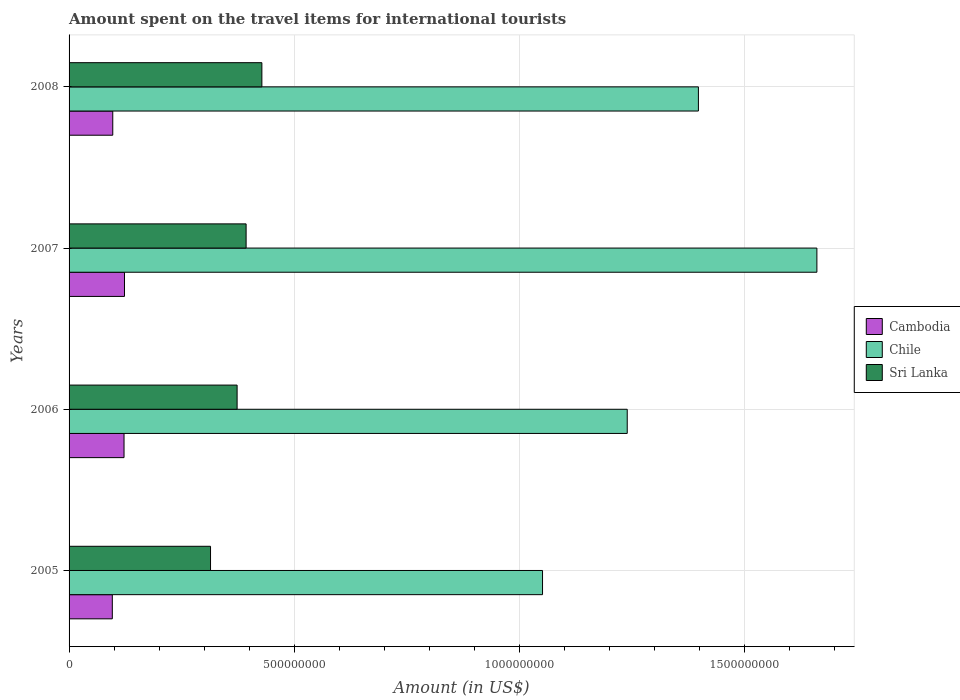How many different coloured bars are there?
Your response must be concise. 3. Are the number of bars per tick equal to the number of legend labels?
Ensure brevity in your answer.  Yes. Are the number of bars on each tick of the Y-axis equal?
Your response must be concise. Yes. How many bars are there on the 4th tick from the bottom?
Your response must be concise. 3. In how many cases, is the number of bars for a given year not equal to the number of legend labels?
Ensure brevity in your answer.  0. What is the amount spent on the travel items for international tourists in Cambodia in 2005?
Your response must be concise. 9.60e+07. Across all years, what is the maximum amount spent on the travel items for international tourists in Chile?
Provide a succinct answer. 1.66e+09. Across all years, what is the minimum amount spent on the travel items for international tourists in Cambodia?
Provide a short and direct response. 9.60e+07. What is the total amount spent on the travel items for international tourists in Cambodia in the graph?
Ensure brevity in your answer.  4.38e+08. What is the difference between the amount spent on the travel items for international tourists in Sri Lanka in 2007 and that in 2008?
Provide a succinct answer. -3.50e+07. What is the difference between the amount spent on the travel items for international tourists in Chile in 2005 and the amount spent on the travel items for international tourists in Sri Lanka in 2007?
Offer a terse response. 6.58e+08. What is the average amount spent on the travel items for international tourists in Sri Lanka per year?
Give a very brief answer. 3.77e+08. In the year 2005, what is the difference between the amount spent on the travel items for international tourists in Chile and amount spent on the travel items for international tourists in Cambodia?
Your response must be concise. 9.55e+08. What is the ratio of the amount spent on the travel items for international tourists in Chile in 2007 to that in 2008?
Offer a terse response. 1.19. Is the difference between the amount spent on the travel items for international tourists in Chile in 2007 and 2008 greater than the difference between the amount spent on the travel items for international tourists in Cambodia in 2007 and 2008?
Keep it short and to the point. Yes. What is the difference between the highest and the second highest amount spent on the travel items for international tourists in Chile?
Provide a succinct answer. 2.63e+08. What is the difference between the highest and the lowest amount spent on the travel items for international tourists in Sri Lanka?
Keep it short and to the point. 1.14e+08. In how many years, is the amount spent on the travel items for international tourists in Chile greater than the average amount spent on the travel items for international tourists in Chile taken over all years?
Provide a succinct answer. 2. What does the 1st bar from the top in 2006 represents?
Your answer should be very brief. Sri Lanka. What does the 3rd bar from the bottom in 2005 represents?
Offer a very short reply. Sri Lanka. Is it the case that in every year, the sum of the amount spent on the travel items for international tourists in Chile and amount spent on the travel items for international tourists in Sri Lanka is greater than the amount spent on the travel items for international tourists in Cambodia?
Your answer should be very brief. Yes. How many bars are there?
Your response must be concise. 12. Are all the bars in the graph horizontal?
Your answer should be compact. Yes. How many years are there in the graph?
Give a very brief answer. 4. What is the difference between two consecutive major ticks on the X-axis?
Give a very brief answer. 5.00e+08. Does the graph contain any zero values?
Offer a very short reply. No. Where does the legend appear in the graph?
Your response must be concise. Center right. What is the title of the graph?
Your response must be concise. Amount spent on the travel items for international tourists. Does "Bahrain" appear as one of the legend labels in the graph?
Provide a short and direct response. No. What is the label or title of the X-axis?
Offer a terse response. Amount (in US$). What is the Amount (in US$) of Cambodia in 2005?
Keep it short and to the point. 9.60e+07. What is the Amount (in US$) in Chile in 2005?
Offer a very short reply. 1.05e+09. What is the Amount (in US$) in Sri Lanka in 2005?
Provide a short and direct response. 3.14e+08. What is the Amount (in US$) of Cambodia in 2006?
Your response must be concise. 1.22e+08. What is the Amount (in US$) in Chile in 2006?
Keep it short and to the point. 1.24e+09. What is the Amount (in US$) in Sri Lanka in 2006?
Offer a very short reply. 3.73e+08. What is the Amount (in US$) in Cambodia in 2007?
Your response must be concise. 1.23e+08. What is the Amount (in US$) in Chile in 2007?
Your response must be concise. 1.66e+09. What is the Amount (in US$) of Sri Lanka in 2007?
Your answer should be very brief. 3.93e+08. What is the Amount (in US$) of Cambodia in 2008?
Offer a terse response. 9.70e+07. What is the Amount (in US$) in Chile in 2008?
Provide a succinct answer. 1.40e+09. What is the Amount (in US$) of Sri Lanka in 2008?
Provide a succinct answer. 4.28e+08. Across all years, what is the maximum Amount (in US$) in Cambodia?
Make the answer very short. 1.23e+08. Across all years, what is the maximum Amount (in US$) in Chile?
Ensure brevity in your answer.  1.66e+09. Across all years, what is the maximum Amount (in US$) in Sri Lanka?
Your answer should be compact. 4.28e+08. Across all years, what is the minimum Amount (in US$) of Cambodia?
Offer a very short reply. 9.60e+07. Across all years, what is the minimum Amount (in US$) of Chile?
Give a very brief answer. 1.05e+09. Across all years, what is the minimum Amount (in US$) in Sri Lanka?
Offer a very short reply. 3.14e+08. What is the total Amount (in US$) in Cambodia in the graph?
Give a very brief answer. 4.38e+08. What is the total Amount (in US$) in Chile in the graph?
Offer a very short reply. 5.35e+09. What is the total Amount (in US$) of Sri Lanka in the graph?
Keep it short and to the point. 1.51e+09. What is the difference between the Amount (in US$) in Cambodia in 2005 and that in 2006?
Your answer should be compact. -2.60e+07. What is the difference between the Amount (in US$) in Chile in 2005 and that in 2006?
Keep it short and to the point. -1.88e+08. What is the difference between the Amount (in US$) in Sri Lanka in 2005 and that in 2006?
Offer a terse response. -5.90e+07. What is the difference between the Amount (in US$) of Cambodia in 2005 and that in 2007?
Provide a succinct answer. -2.70e+07. What is the difference between the Amount (in US$) of Chile in 2005 and that in 2007?
Give a very brief answer. -6.09e+08. What is the difference between the Amount (in US$) of Sri Lanka in 2005 and that in 2007?
Your answer should be compact. -7.90e+07. What is the difference between the Amount (in US$) of Cambodia in 2005 and that in 2008?
Your answer should be very brief. -1.00e+06. What is the difference between the Amount (in US$) of Chile in 2005 and that in 2008?
Your answer should be very brief. -3.46e+08. What is the difference between the Amount (in US$) of Sri Lanka in 2005 and that in 2008?
Provide a short and direct response. -1.14e+08. What is the difference between the Amount (in US$) in Cambodia in 2006 and that in 2007?
Your answer should be compact. -1.00e+06. What is the difference between the Amount (in US$) in Chile in 2006 and that in 2007?
Your response must be concise. -4.21e+08. What is the difference between the Amount (in US$) in Sri Lanka in 2006 and that in 2007?
Offer a terse response. -2.00e+07. What is the difference between the Amount (in US$) of Cambodia in 2006 and that in 2008?
Ensure brevity in your answer.  2.50e+07. What is the difference between the Amount (in US$) in Chile in 2006 and that in 2008?
Provide a short and direct response. -1.58e+08. What is the difference between the Amount (in US$) of Sri Lanka in 2006 and that in 2008?
Your response must be concise. -5.50e+07. What is the difference between the Amount (in US$) of Cambodia in 2007 and that in 2008?
Your response must be concise. 2.60e+07. What is the difference between the Amount (in US$) in Chile in 2007 and that in 2008?
Provide a short and direct response. 2.63e+08. What is the difference between the Amount (in US$) in Sri Lanka in 2007 and that in 2008?
Keep it short and to the point. -3.50e+07. What is the difference between the Amount (in US$) in Cambodia in 2005 and the Amount (in US$) in Chile in 2006?
Your response must be concise. -1.14e+09. What is the difference between the Amount (in US$) of Cambodia in 2005 and the Amount (in US$) of Sri Lanka in 2006?
Provide a short and direct response. -2.77e+08. What is the difference between the Amount (in US$) of Chile in 2005 and the Amount (in US$) of Sri Lanka in 2006?
Your answer should be compact. 6.78e+08. What is the difference between the Amount (in US$) in Cambodia in 2005 and the Amount (in US$) in Chile in 2007?
Ensure brevity in your answer.  -1.56e+09. What is the difference between the Amount (in US$) of Cambodia in 2005 and the Amount (in US$) of Sri Lanka in 2007?
Your answer should be very brief. -2.97e+08. What is the difference between the Amount (in US$) in Chile in 2005 and the Amount (in US$) in Sri Lanka in 2007?
Your response must be concise. 6.58e+08. What is the difference between the Amount (in US$) in Cambodia in 2005 and the Amount (in US$) in Chile in 2008?
Your response must be concise. -1.30e+09. What is the difference between the Amount (in US$) in Cambodia in 2005 and the Amount (in US$) in Sri Lanka in 2008?
Your response must be concise. -3.32e+08. What is the difference between the Amount (in US$) of Chile in 2005 and the Amount (in US$) of Sri Lanka in 2008?
Make the answer very short. 6.23e+08. What is the difference between the Amount (in US$) in Cambodia in 2006 and the Amount (in US$) in Chile in 2007?
Offer a very short reply. -1.54e+09. What is the difference between the Amount (in US$) of Cambodia in 2006 and the Amount (in US$) of Sri Lanka in 2007?
Your answer should be compact. -2.71e+08. What is the difference between the Amount (in US$) in Chile in 2006 and the Amount (in US$) in Sri Lanka in 2007?
Provide a succinct answer. 8.46e+08. What is the difference between the Amount (in US$) of Cambodia in 2006 and the Amount (in US$) of Chile in 2008?
Give a very brief answer. -1.28e+09. What is the difference between the Amount (in US$) in Cambodia in 2006 and the Amount (in US$) in Sri Lanka in 2008?
Give a very brief answer. -3.06e+08. What is the difference between the Amount (in US$) of Chile in 2006 and the Amount (in US$) of Sri Lanka in 2008?
Offer a terse response. 8.11e+08. What is the difference between the Amount (in US$) in Cambodia in 2007 and the Amount (in US$) in Chile in 2008?
Your response must be concise. -1.27e+09. What is the difference between the Amount (in US$) in Cambodia in 2007 and the Amount (in US$) in Sri Lanka in 2008?
Offer a terse response. -3.05e+08. What is the difference between the Amount (in US$) of Chile in 2007 and the Amount (in US$) of Sri Lanka in 2008?
Your answer should be compact. 1.23e+09. What is the average Amount (in US$) in Cambodia per year?
Keep it short and to the point. 1.10e+08. What is the average Amount (in US$) in Chile per year?
Offer a very short reply. 1.34e+09. What is the average Amount (in US$) of Sri Lanka per year?
Your answer should be very brief. 3.77e+08. In the year 2005, what is the difference between the Amount (in US$) in Cambodia and Amount (in US$) in Chile?
Your answer should be compact. -9.55e+08. In the year 2005, what is the difference between the Amount (in US$) in Cambodia and Amount (in US$) in Sri Lanka?
Keep it short and to the point. -2.18e+08. In the year 2005, what is the difference between the Amount (in US$) of Chile and Amount (in US$) of Sri Lanka?
Offer a very short reply. 7.37e+08. In the year 2006, what is the difference between the Amount (in US$) in Cambodia and Amount (in US$) in Chile?
Your answer should be very brief. -1.12e+09. In the year 2006, what is the difference between the Amount (in US$) of Cambodia and Amount (in US$) of Sri Lanka?
Your answer should be compact. -2.51e+08. In the year 2006, what is the difference between the Amount (in US$) of Chile and Amount (in US$) of Sri Lanka?
Keep it short and to the point. 8.66e+08. In the year 2007, what is the difference between the Amount (in US$) of Cambodia and Amount (in US$) of Chile?
Offer a very short reply. -1.54e+09. In the year 2007, what is the difference between the Amount (in US$) in Cambodia and Amount (in US$) in Sri Lanka?
Offer a very short reply. -2.70e+08. In the year 2007, what is the difference between the Amount (in US$) of Chile and Amount (in US$) of Sri Lanka?
Offer a terse response. 1.27e+09. In the year 2008, what is the difference between the Amount (in US$) of Cambodia and Amount (in US$) of Chile?
Your answer should be compact. -1.30e+09. In the year 2008, what is the difference between the Amount (in US$) of Cambodia and Amount (in US$) of Sri Lanka?
Your answer should be very brief. -3.31e+08. In the year 2008, what is the difference between the Amount (in US$) in Chile and Amount (in US$) in Sri Lanka?
Your response must be concise. 9.69e+08. What is the ratio of the Amount (in US$) of Cambodia in 2005 to that in 2006?
Give a very brief answer. 0.79. What is the ratio of the Amount (in US$) in Chile in 2005 to that in 2006?
Make the answer very short. 0.85. What is the ratio of the Amount (in US$) in Sri Lanka in 2005 to that in 2006?
Provide a succinct answer. 0.84. What is the ratio of the Amount (in US$) in Cambodia in 2005 to that in 2007?
Offer a terse response. 0.78. What is the ratio of the Amount (in US$) in Chile in 2005 to that in 2007?
Your response must be concise. 0.63. What is the ratio of the Amount (in US$) in Sri Lanka in 2005 to that in 2007?
Keep it short and to the point. 0.8. What is the ratio of the Amount (in US$) in Chile in 2005 to that in 2008?
Provide a short and direct response. 0.75. What is the ratio of the Amount (in US$) of Sri Lanka in 2005 to that in 2008?
Ensure brevity in your answer.  0.73. What is the ratio of the Amount (in US$) in Cambodia in 2006 to that in 2007?
Provide a succinct answer. 0.99. What is the ratio of the Amount (in US$) in Chile in 2006 to that in 2007?
Provide a succinct answer. 0.75. What is the ratio of the Amount (in US$) of Sri Lanka in 2006 to that in 2007?
Ensure brevity in your answer.  0.95. What is the ratio of the Amount (in US$) of Cambodia in 2006 to that in 2008?
Make the answer very short. 1.26. What is the ratio of the Amount (in US$) of Chile in 2006 to that in 2008?
Offer a terse response. 0.89. What is the ratio of the Amount (in US$) of Sri Lanka in 2006 to that in 2008?
Provide a short and direct response. 0.87. What is the ratio of the Amount (in US$) of Cambodia in 2007 to that in 2008?
Provide a short and direct response. 1.27. What is the ratio of the Amount (in US$) of Chile in 2007 to that in 2008?
Make the answer very short. 1.19. What is the ratio of the Amount (in US$) in Sri Lanka in 2007 to that in 2008?
Offer a very short reply. 0.92. What is the difference between the highest and the second highest Amount (in US$) in Cambodia?
Make the answer very short. 1.00e+06. What is the difference between the highest and the second highest Amount (in US$) of Chile?
Make the answer very short. 2.63e+08. What is the difference between the highest and the second highest Amount (in US$) in Sri Lanka?
Offer a very short reply. 3.50e+07. What is the difference between the highest and the lowest Amount (in US$) of Cambodia?
Make the answer very short. 2.70e+07. What is the difference between the highest and the lowest Amount (in US$) in Chile?
Your answer should be compact. 6.09e+08. What is the difference between the highest and the lowest Amount (in US$) in Sri Lanka?
Keep it short and to the point. 1.14e+08. 